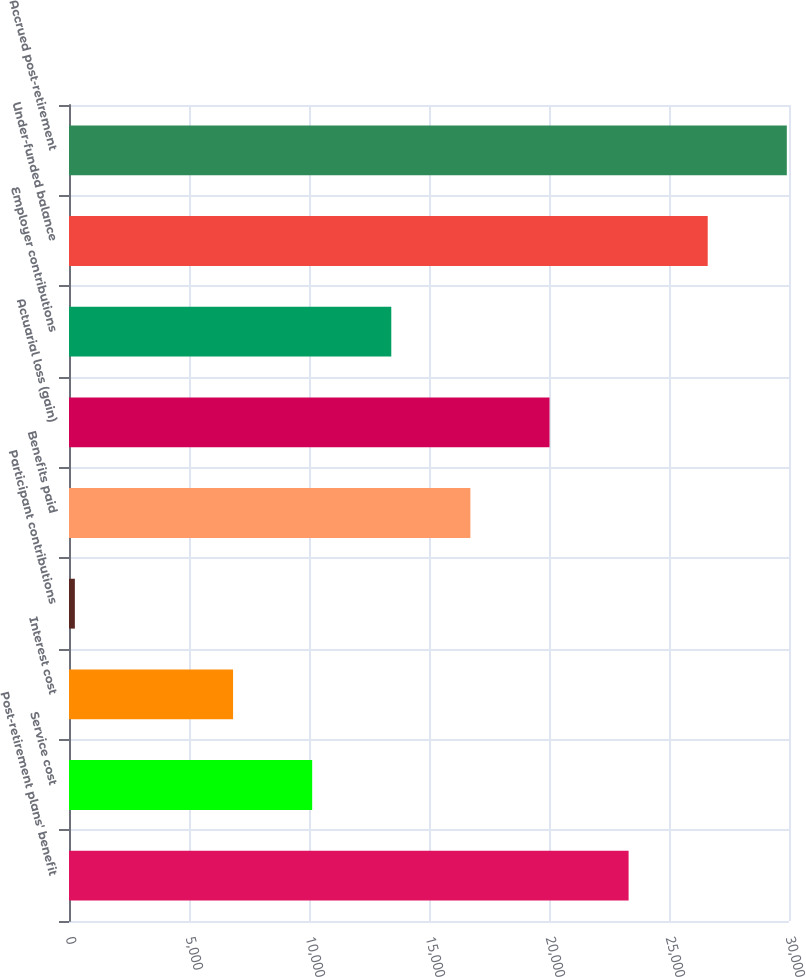Convert chart. <chart><loc_0><loc_0><loc_500><loc_500><bar_chart><fcel>Post-retirement plans' benefit<fcel>Service cost<fcel>Interest cost<fcel>Participant contributions<fcel>Benefits paid<fcel>Actuarial loss (gain)<fcel>Employer contributions<fcel>Under-funded balance<fcel>Accrued post-retirement<nl><fcel>23316.7<fcel>10132.3<fcel>6836.2<fcel>244<fcel>16724.5<fcel>20020.6<fcel>13428.4<fcel>26612.8<fcel>29908.9<nl></chart> 